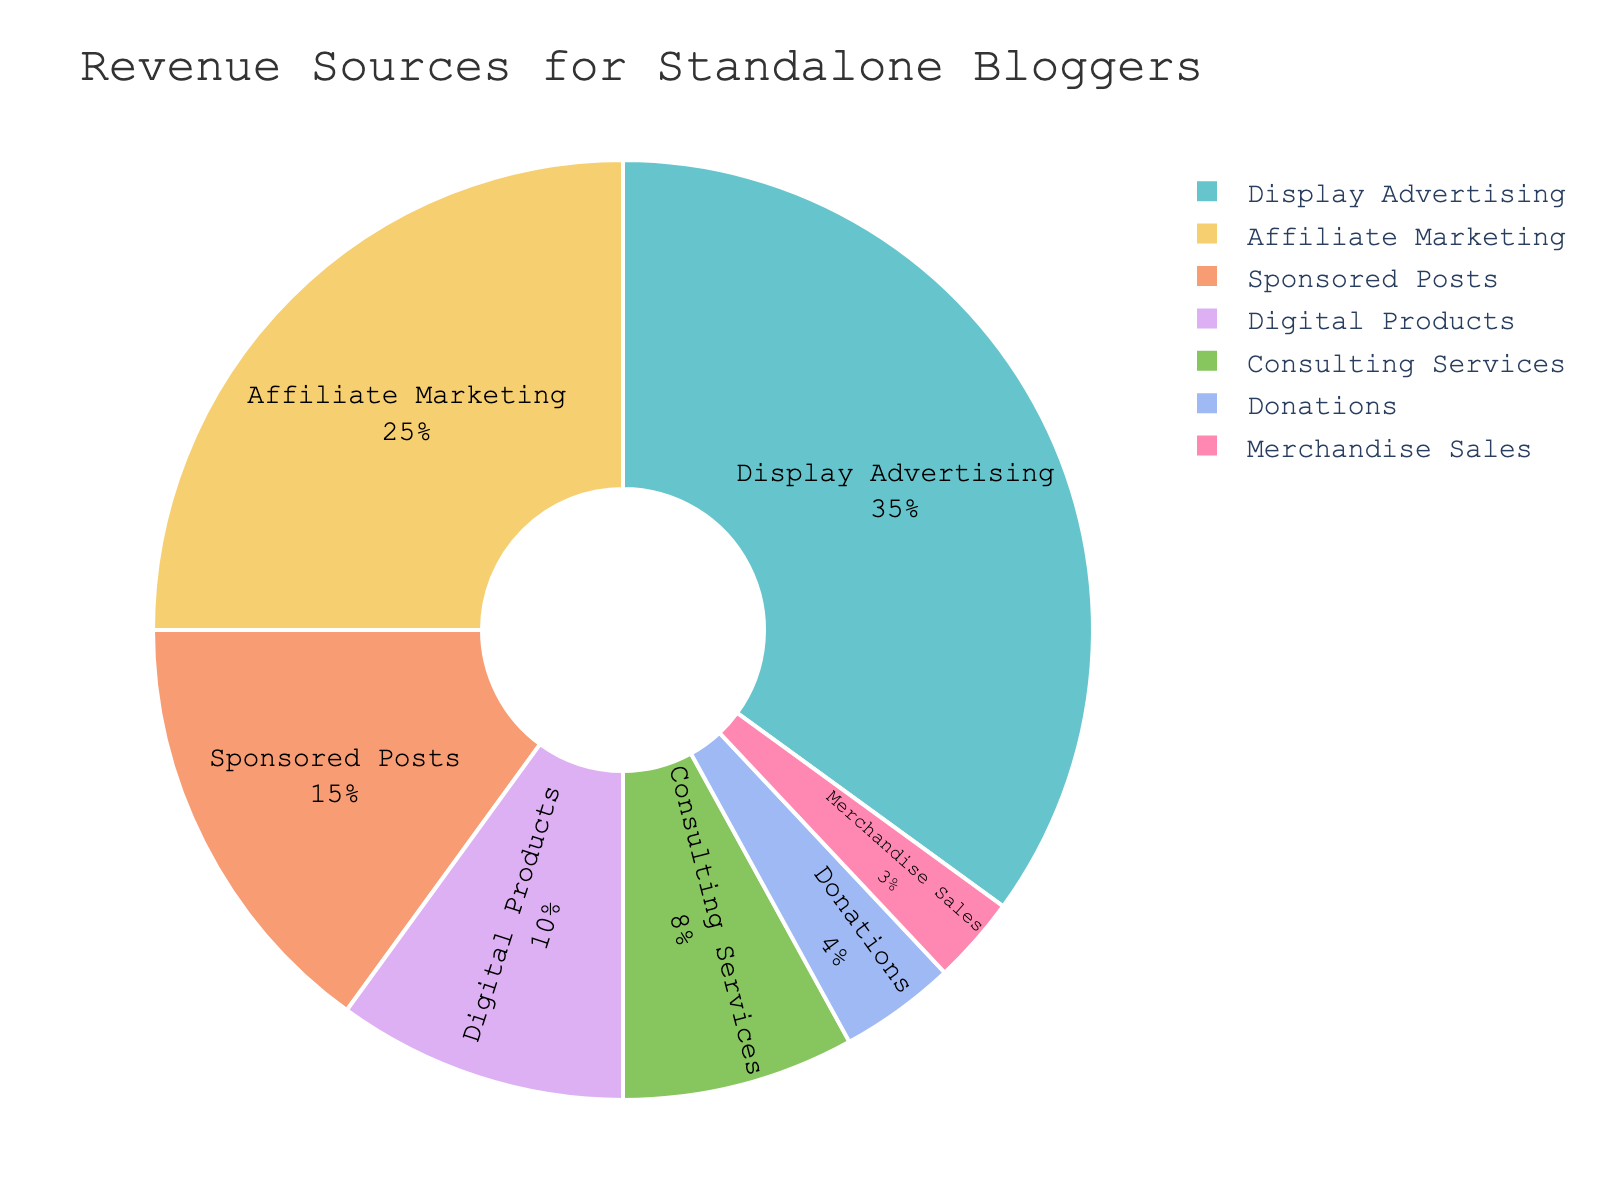What is the largest source of revenue for standalone bloggers? The largest portion of the pie chart is "Display Advertising," which is represented by the largest slice in the pie. This indicates it is the most significant source of revenue, comprising 35% of the total.
Answer: Display Advertising What is the combined percentage of revenue from Consulting Services and Digital Products? First, identify the percentages of each source: Consulting Services (8%) and Digital Products (10%). Adding these together gives 8% + 10% = 18%.
Answer: 18% Which revenue source contributes less than Sponsored Posts but more than Donations? Consulting Services at 8% is less than Sponsored Posts at 15% and more than Donations at 4%.
Answer: Consulting Services How many revenue sources contribute more than 10% of the total revenue? By examining the pie chart, the sources contributing more than 10% are Display Advertising (35%), Affiliate Marketing (25%), and Sponsored Posts (15%). This totals three sources.
Answer: 3 What is the percentage difference between Affiliate Marketing and Merchandise Sales? Refer to their percentages: Affiliate Marketing (25%) and Merchandise Sales (3%). The difference is 25% - 3% = 22%.
Answer: 22% Rank the revenue sources from highest to lowest percentage. The highest to lowest percentages as shown in the pie chart are: Display Advertising (35%), Affiliate Marketing (25%), Sponsored Posts (15%), Digital Products (10%), Consulting Services (8%), Donations (4%), Merchandise Sales (3%).
Answer: Display Advertising, Affiliate Marketing, Sponsored Posts, Digital Products, Consulting Services, Donations, Merchandise Sales Which revenue source has the smallest contribution? The smallest slice of the pie chart represents Merchandise Sales, which is 3%.
Answer: Merchandise Sales What is the total percentage of revenue from non-advertising sources? The non-advertising sources are Affiliate Marketing (25%), Sponsored Posts (15%), Digital Products (10%), Consulting Services (8%), Donations (4%), and Merchandise Sales (3%). Adding these gives 25% + 15% + 10% + 8% + 4% + 3% = 65%.
Answer: 65% By what percentage is Display Advertising greater than Digital Products? Display Advertising is 35% and Digital Products is 10%. The difference is 35% - 10% = 25%.
Answer: 25% 